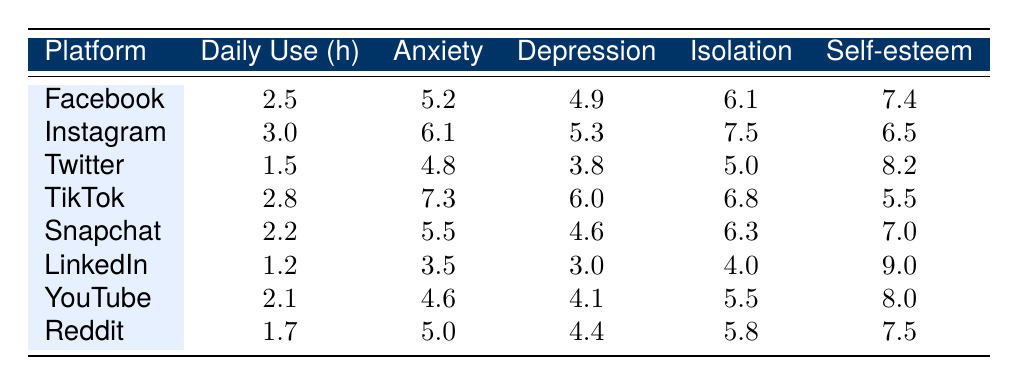What is the average daily use of Instagram in hours? The table shows that Instagram has an average daily use of 3.0 hours.
Answer: 3.0 Which platform has the highest social isolation score? Looking at the social isolation scores in the table, Instagram has the highest score of 7.5.
Answer: Instagram What is the anxiety score for Twitter? The table indicates that Twitter has an anxiety score of 4.8.
Answer: 4.8 If a person uses TikTok for 2.8 hours daily, what is their self-esteem score? The self-esteem score for TikTok is given as 5.5 in the table.
Answer: 5.5 True or False: Users of LinkedIn have the lowest anxiety score among all platforms. The table shows LinkedIn has an anxiety score of 3.5, which is indeed the lowest compared to all other platforms.
Answer: True What is the difference in the depression scores between Instagram and TikTok? The depression score for Instagram is 5.3 and for TikTok is 6.0. The difference is 6.0 - 5.3 = 0.7.
Answer: 0.7 Which platform has the lowest average daily use hours and what is its score for self-esteem? LinkedIn has the lowest average daily use of 1.2 hours, and its self-esteem score is 9.0.
Answer: LinkedIn, 9.0 Calculate the average anxiety score across all platforms. The anxiety scores are 5.2, 6.1, 4.8, 7.3, 5.5, 3.5, 4.6, and 5.0. Summing these gives 38.0. There are 8 platforms, so the average is 38.0 / 8 = 4.75.
Answer: 4.75 Which platform has a higher self-esteem score: YouTube or Snapchat? YouTube has a self-esteem score of 8.0 and Snapchat has 7.0. Therefore, YouTube has a higher score.
Answer: YouTube What is the correlation between average daily use hours and self-esteem for the platforms listed? The correlation is not directly calculated from the data presented, but from a quick glance, it appears that as daily use increases, self-esteem varies without a clear trend. To get a definitive answer, a statistical analysis would be required.
Answer: Cannot determine from table 